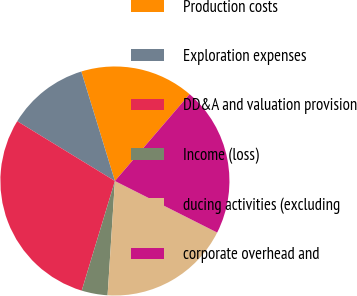<chart> <loc_0><loc_0><loc_500><loc_500><pie_chart><fcel>Production costs<fcel>Exploration expenses<fcel>DD&A and valuation provision<fcel>Income (loss)<fcel>ducing activities (excluding<fcel>corporate overhead and<nl><fcel>16.05%<fcel>11.52%<fcel>29.07%<fcel>3.66%<fcel>18.59%<fcel>21.13%<nl></chart> 